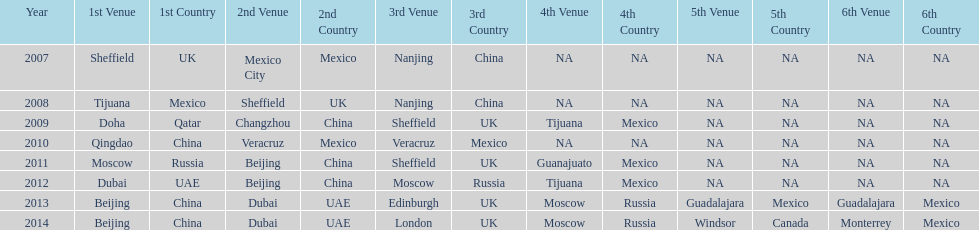Name a year whose second venue was the same as 2011. 2012. Can you parse all the data within this table? {'header': ['Year', '1st Venue', '1st Country', '2nd Venue', '2nd Country', '3rd Venue', '3rd Country', '4th Venue', '4th Country', '5th Venue', '5th Country', '6th Venue', '6th Country'], 'rows': [['2007', 'Sheffield', 'UK', 'Mexico City', 'Mexico', 'Nanjing', 'China', 'NA', 'NA', 'NA', 'NA', 'NA', 'NA'], ['2008', 'Tijuana', 'Mexico', 'Sheffield', 'UK', 'Nanjing', 'China', 'NA', 'NA', 'NA', 'NA', 'NA', 'NA'], ['2009', 'Doha', 'Qatar', 'Changzhou', 'China', 'Sheffield', 'UK', 'Tijuana', 'Mexico', 'NA', 'NA', 'NA', 'NA'], ['2010', 'Qingdao', 'China', 'Veracruz', 'Mexico', 'Veracruz', 'Mexico', 'NA', 'NA', 'NA', 'NA', 'NA', 'NA'], ['2011', 'Moscow', 'Russia', 'Beijing', 'China', 'Sheffield', 'UK', 'Guanajuato', 'Mexico', 'NA', 'NA', 'NA', 'NA'], ['2012', 'Dubai', 'UAE', 'Beijing', 'China', 'Moscow', 'Russia', 'Tijuana', 'Mexico', 'NA', 'NA', 'NA', 'NA'], ['2013', 'Beijing', 'China', 'Dubai', 'UAE', 'Edinburgh', 'UK', 'Moscow', 'Russia', 'Guadalajara', 'Mexico', 'Guadalajara', 'Mexico'], ['2014', 'Beijing', 'China', 'Dubai', 'UAE', 'London', 'UK', 'Moscow', 'Russia', 'Windsor', 'Canada', 'Monterrey', 'Mexico']]} 